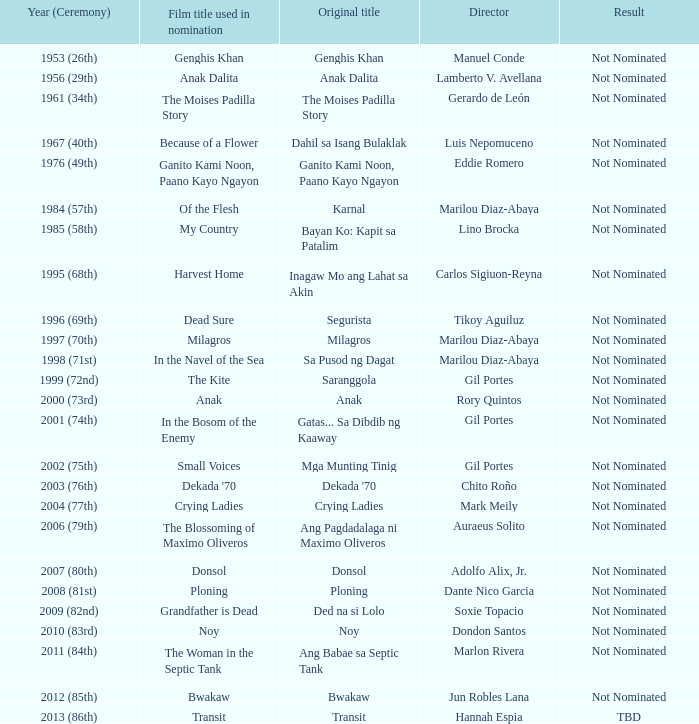Who was the director of Small Voices, a film title used in nomination? Gil Portes. 